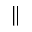Convert formula to latex. <formula><loc_0><loc_0><loc_500><loc_500>\|</formula> 